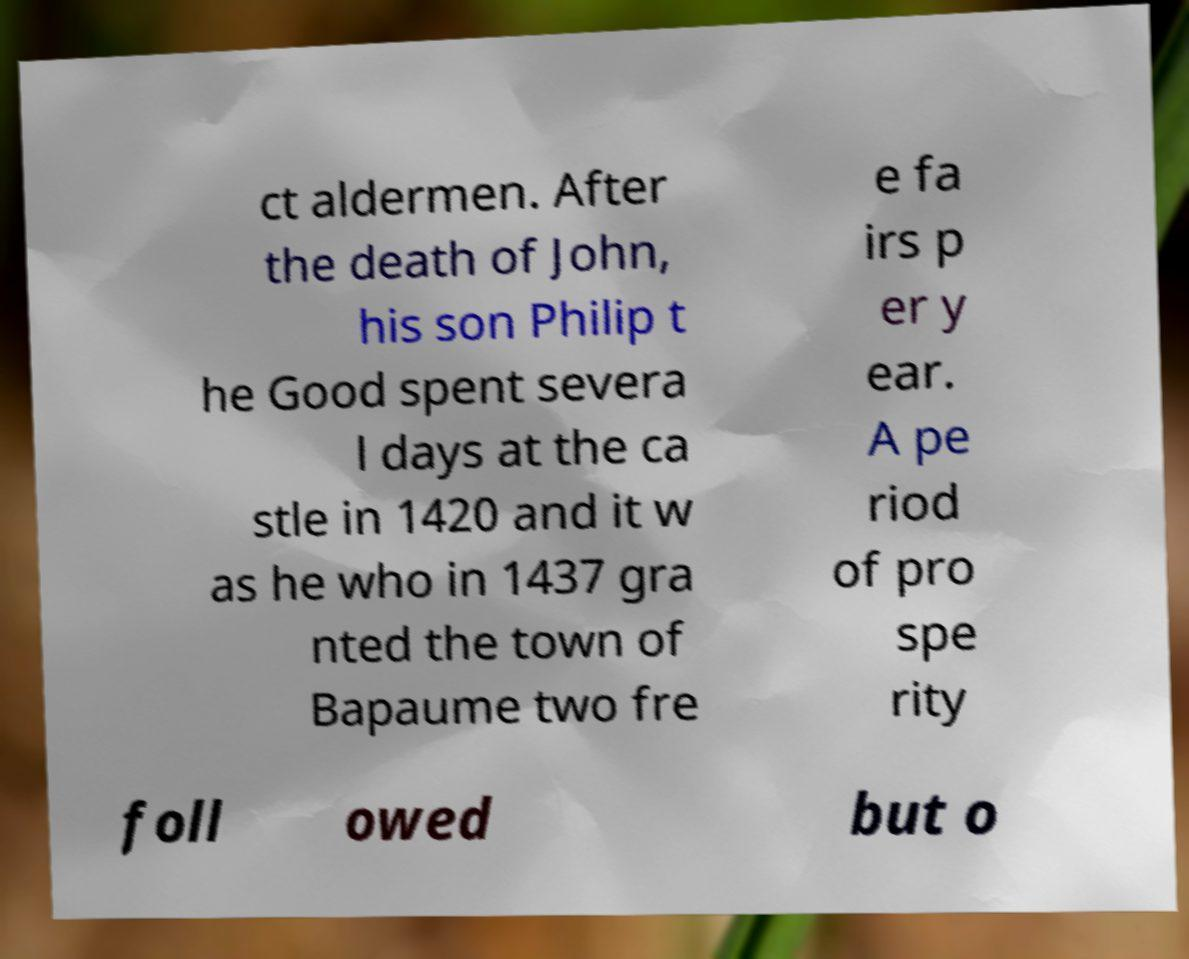There's text embedded in this image that I need extracted. Can you transcribe it verbatim? ct aldermen. After the death of John, his son Philip t he Good spent severa l days at the ca stle in 1420 and it w as he who in 1437 gra nted the town of Bapaume two fre e fa irs p er y ear. A pe riod of pro spe rity foll owed but o 